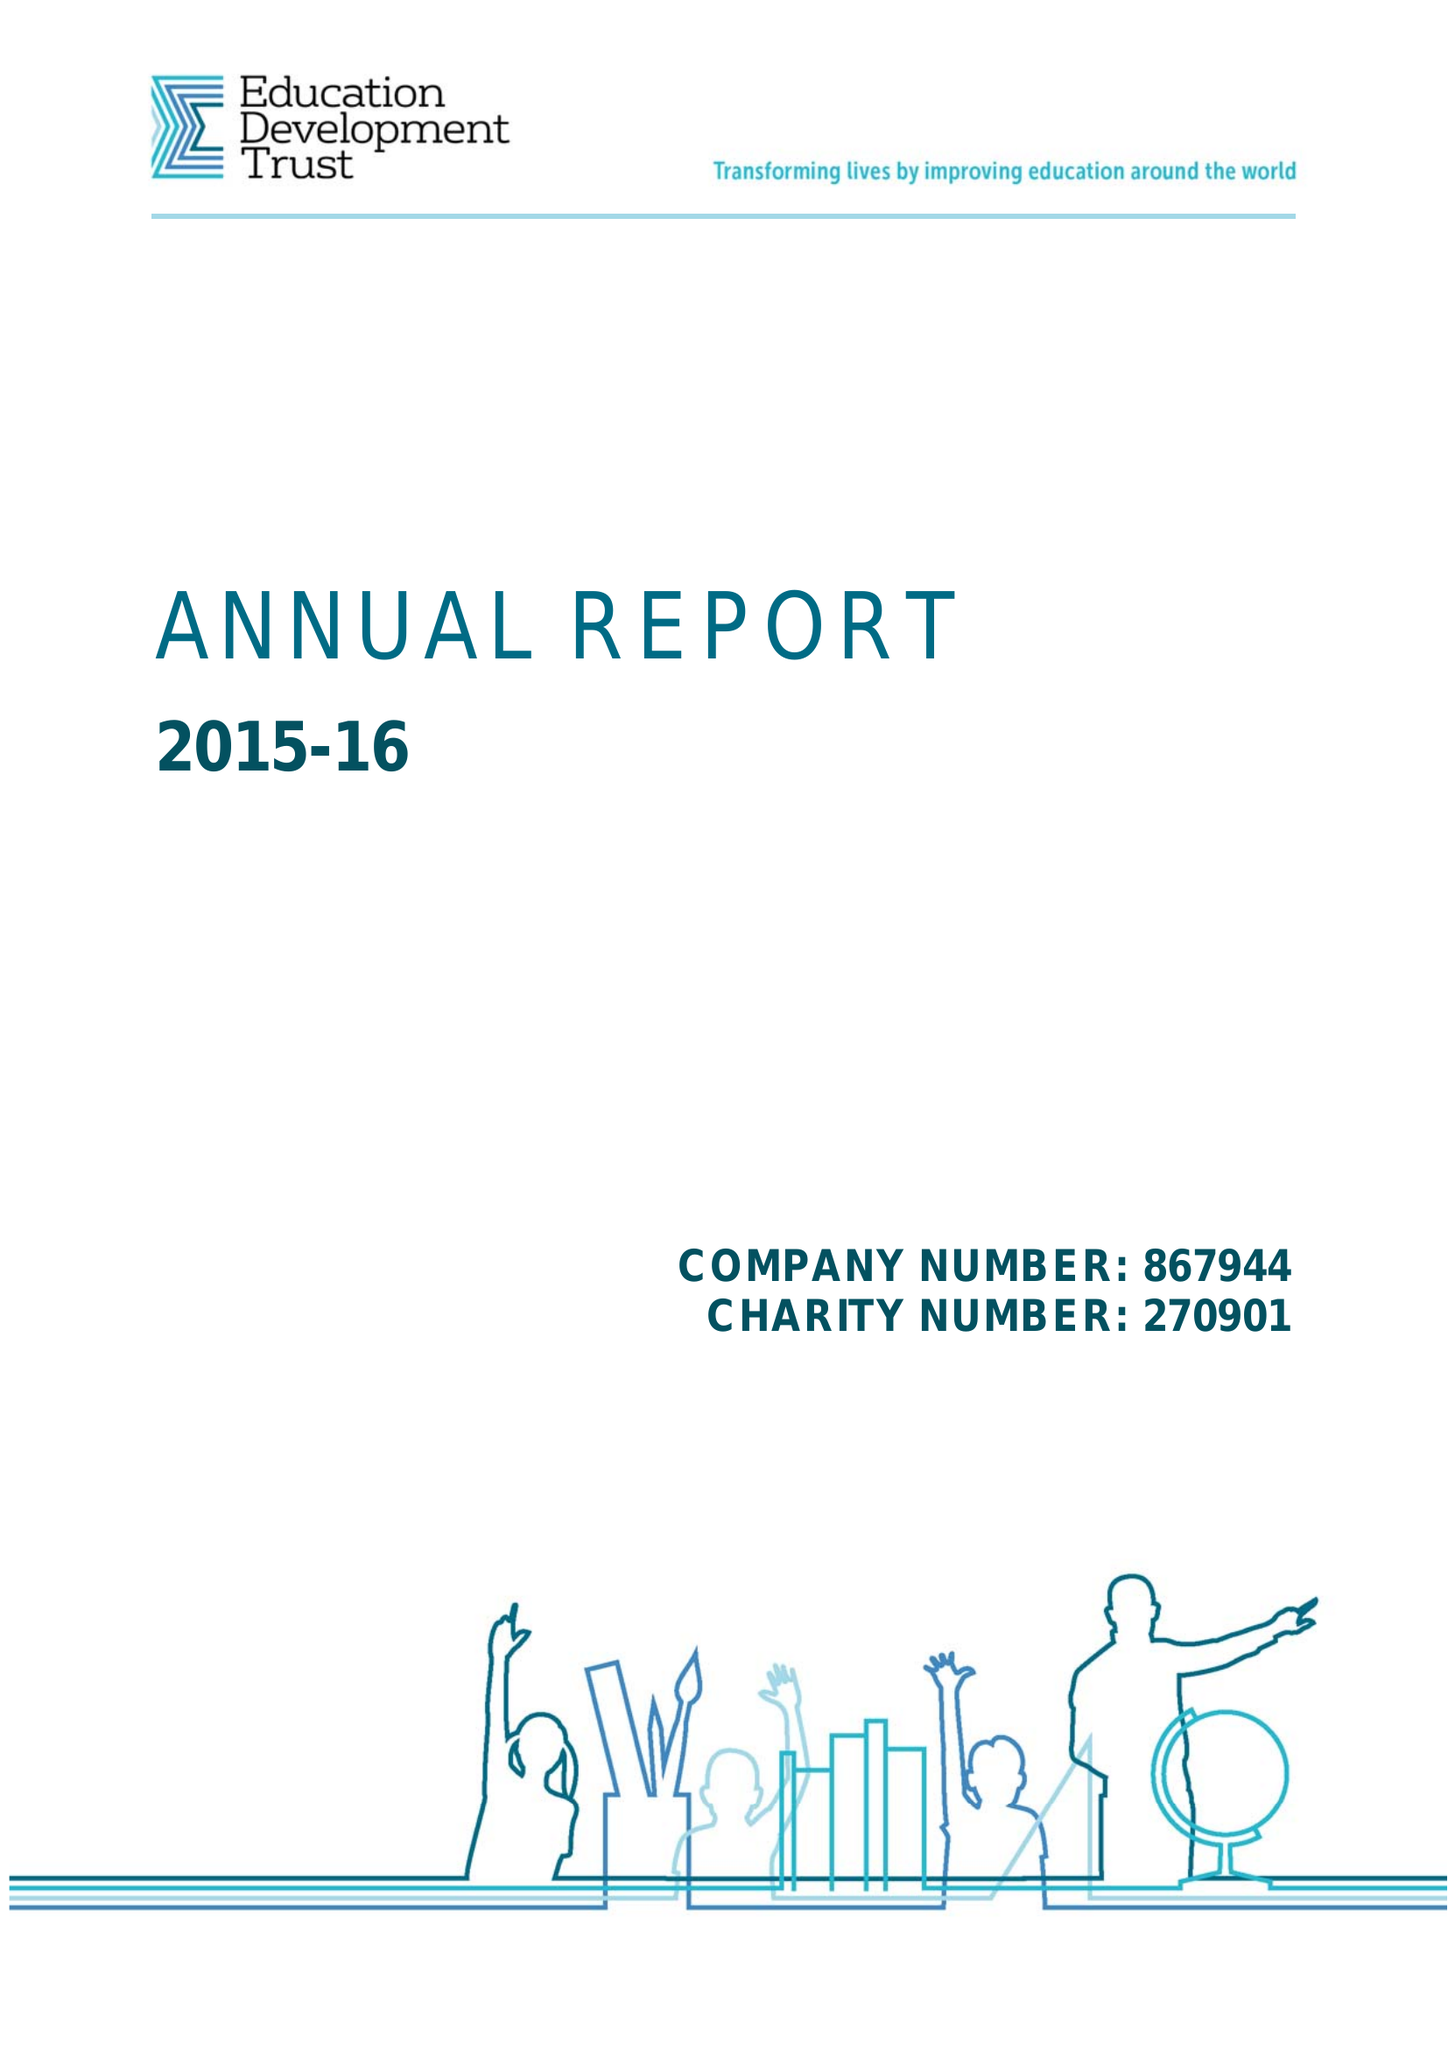What is the value for the income_annually_in_british_pounds?
Answer the question using a single word or phrase. 68845000.00 